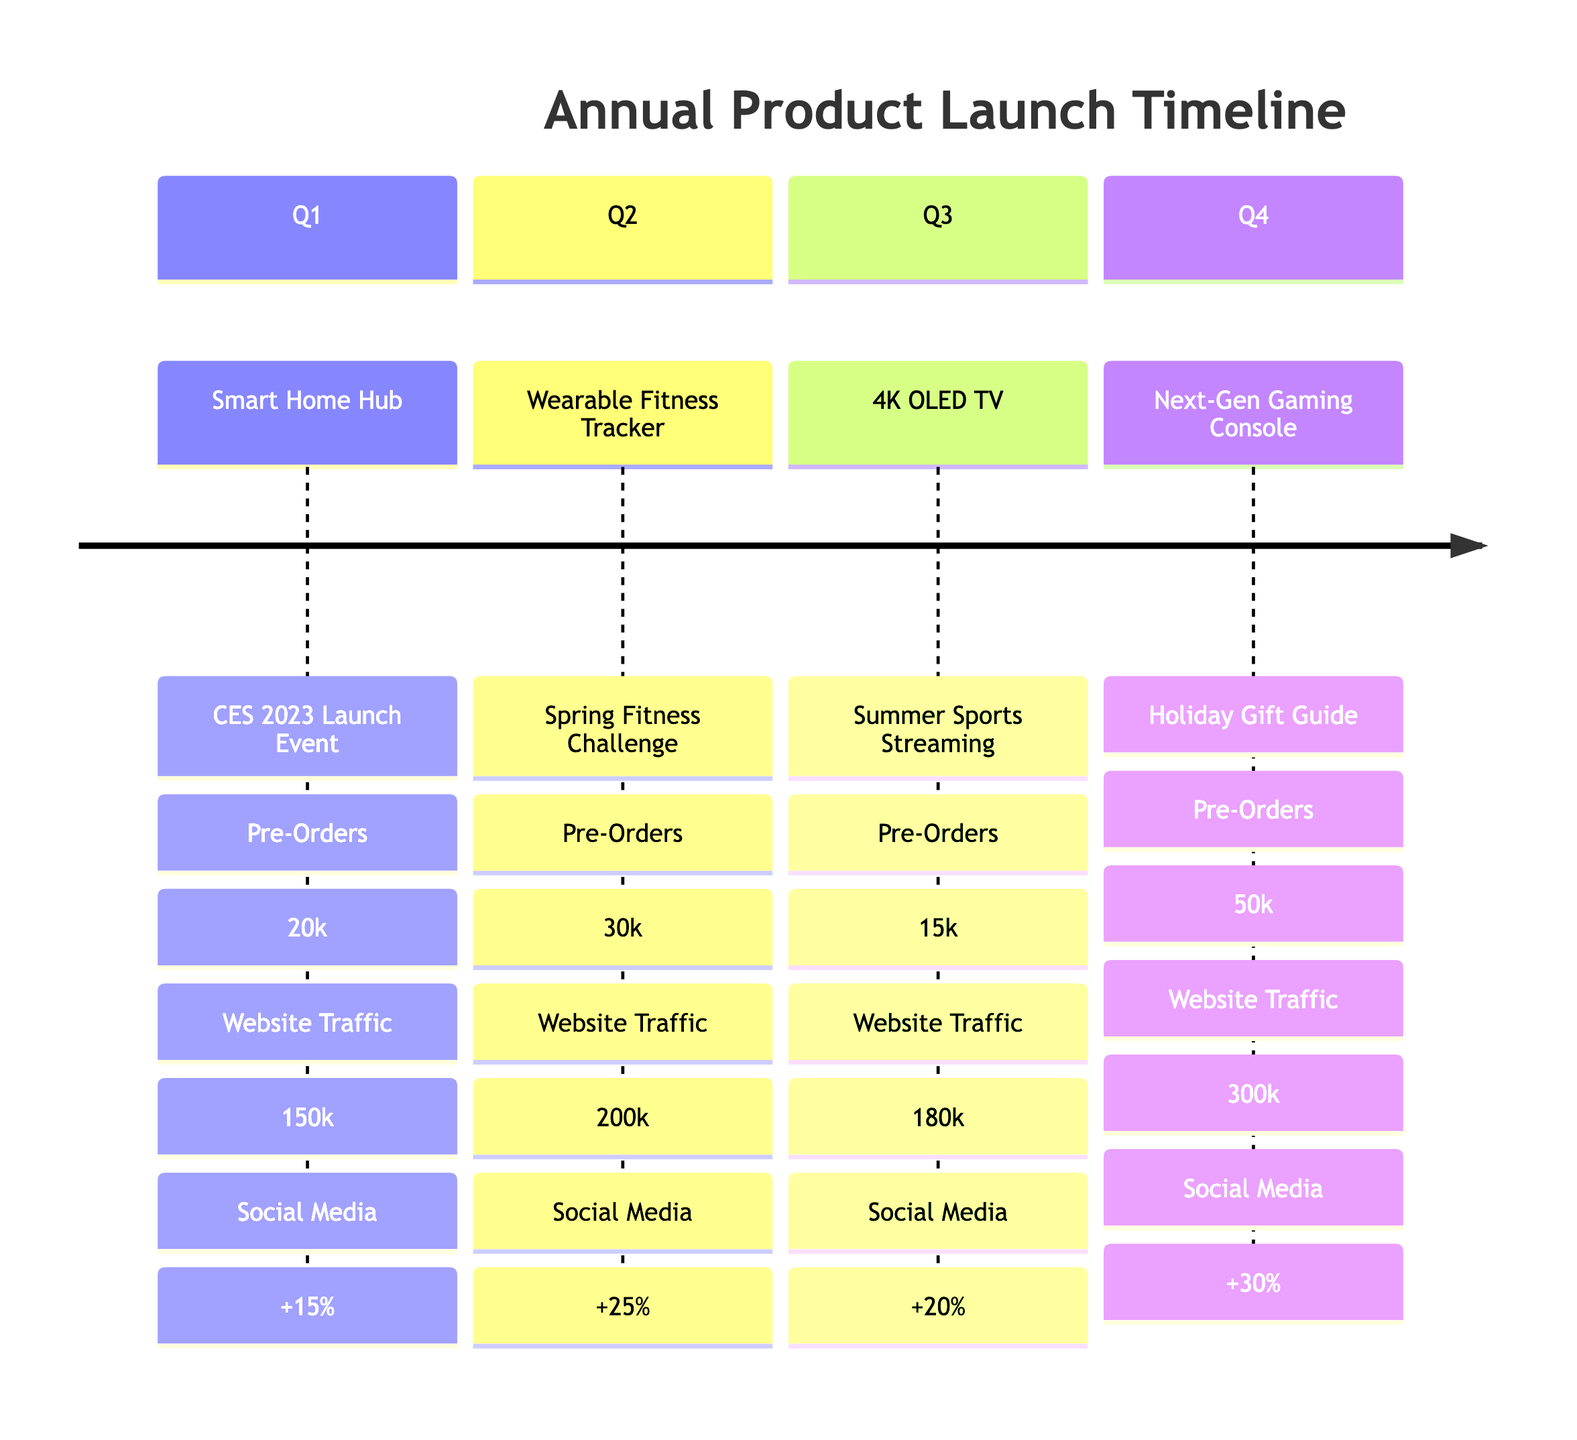What product was launched in Q2? The diagram lists the product launches by quarter. In Q2, the product mentioned is the "Wearable Fitness Tracker."
Answer: Wearable Fitness Tracker How many pre-orders were received for the Smart Home Hub? The diagram indicates that in Q1, the Smart Home Hub received 20,000 pre-orders.
Answer: 20,000 Which marketing campaign was associated with the Next-Gen Gaming Console? According to the diagram, the marketing campaign for the Next-Gen Gaming Console launched in Q4 is the "Holiday Gift Guide."
Answer: Holiday Gift Guide What was the increase in social media engagement for the Wearable Fitness Tracker? The diagram shows a 25% increase in social media engagement associated with the Wearable Fitness Tracker during Q2.
Answer: 25% increase Which quarter had the highest website traffic? By reviewing the website traffic values across all quarters, Q4 shows the highest traffic with 300,000.
Answer: Q4 How many pre-orders were there in Q3 compared to Q2? In Q2, there were 30,000 pre-orders for the Wearable Fitness Tracker, while in Q3 for the 4K OLED TV, there were only 15,000 pre-orders. Thus, Q3 had 15,000 fewer pre-orders than Q2.
Answer: 15,000 fewer What is the total sum of pre-orders across all products? The total pre-orders are calculated by adding all the pre-orders from each quarter: 20,000 (Q1) + 30,000 (Q2) + 15,000 (Q3) + 50,000 (Q4) = 115,000.
Answer: 115,000 Which product had the lowest pre-orders? After analyzing the pre-order figures in the diagram, the product with the lowest pre-orders is the 4K OLED TV with 15,000 pre-orders in Q3.
Answer: 4K OLED TV How does the social media engagement of Q4 compare to Q1? The social media engagement in Q4 shows a 30% increase, compared to a 15% increase in Q1. Thus, Q4 has a 15% higher engagement than Q1.
Answer: 15% higher 